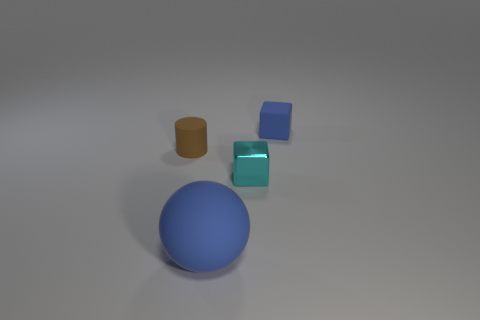Add 4 large blue metal balls. How many objects exist? 8 Subtract all cyan cubes. How many cubes are left? 1 Subtract all gray cubes. Subtract all brown balls. How many cubes are left? 2 Subtract all blue cubes. How many green cylinders are left? 0 Subtract all matte cylinders. Subtract all matte cylinders. How many objects are left? 2 Add 3 rubber balls. How many rubber balls are left? 4 Add 1 large brown matte blocks. How many large brown matte blocks exist? 1 Subtract 0 brown spheres. How many objects are left? 4 Subtract all cylinders. How many objects are left? 3 Subtract 1 blocks. How many blocks are left? 1 